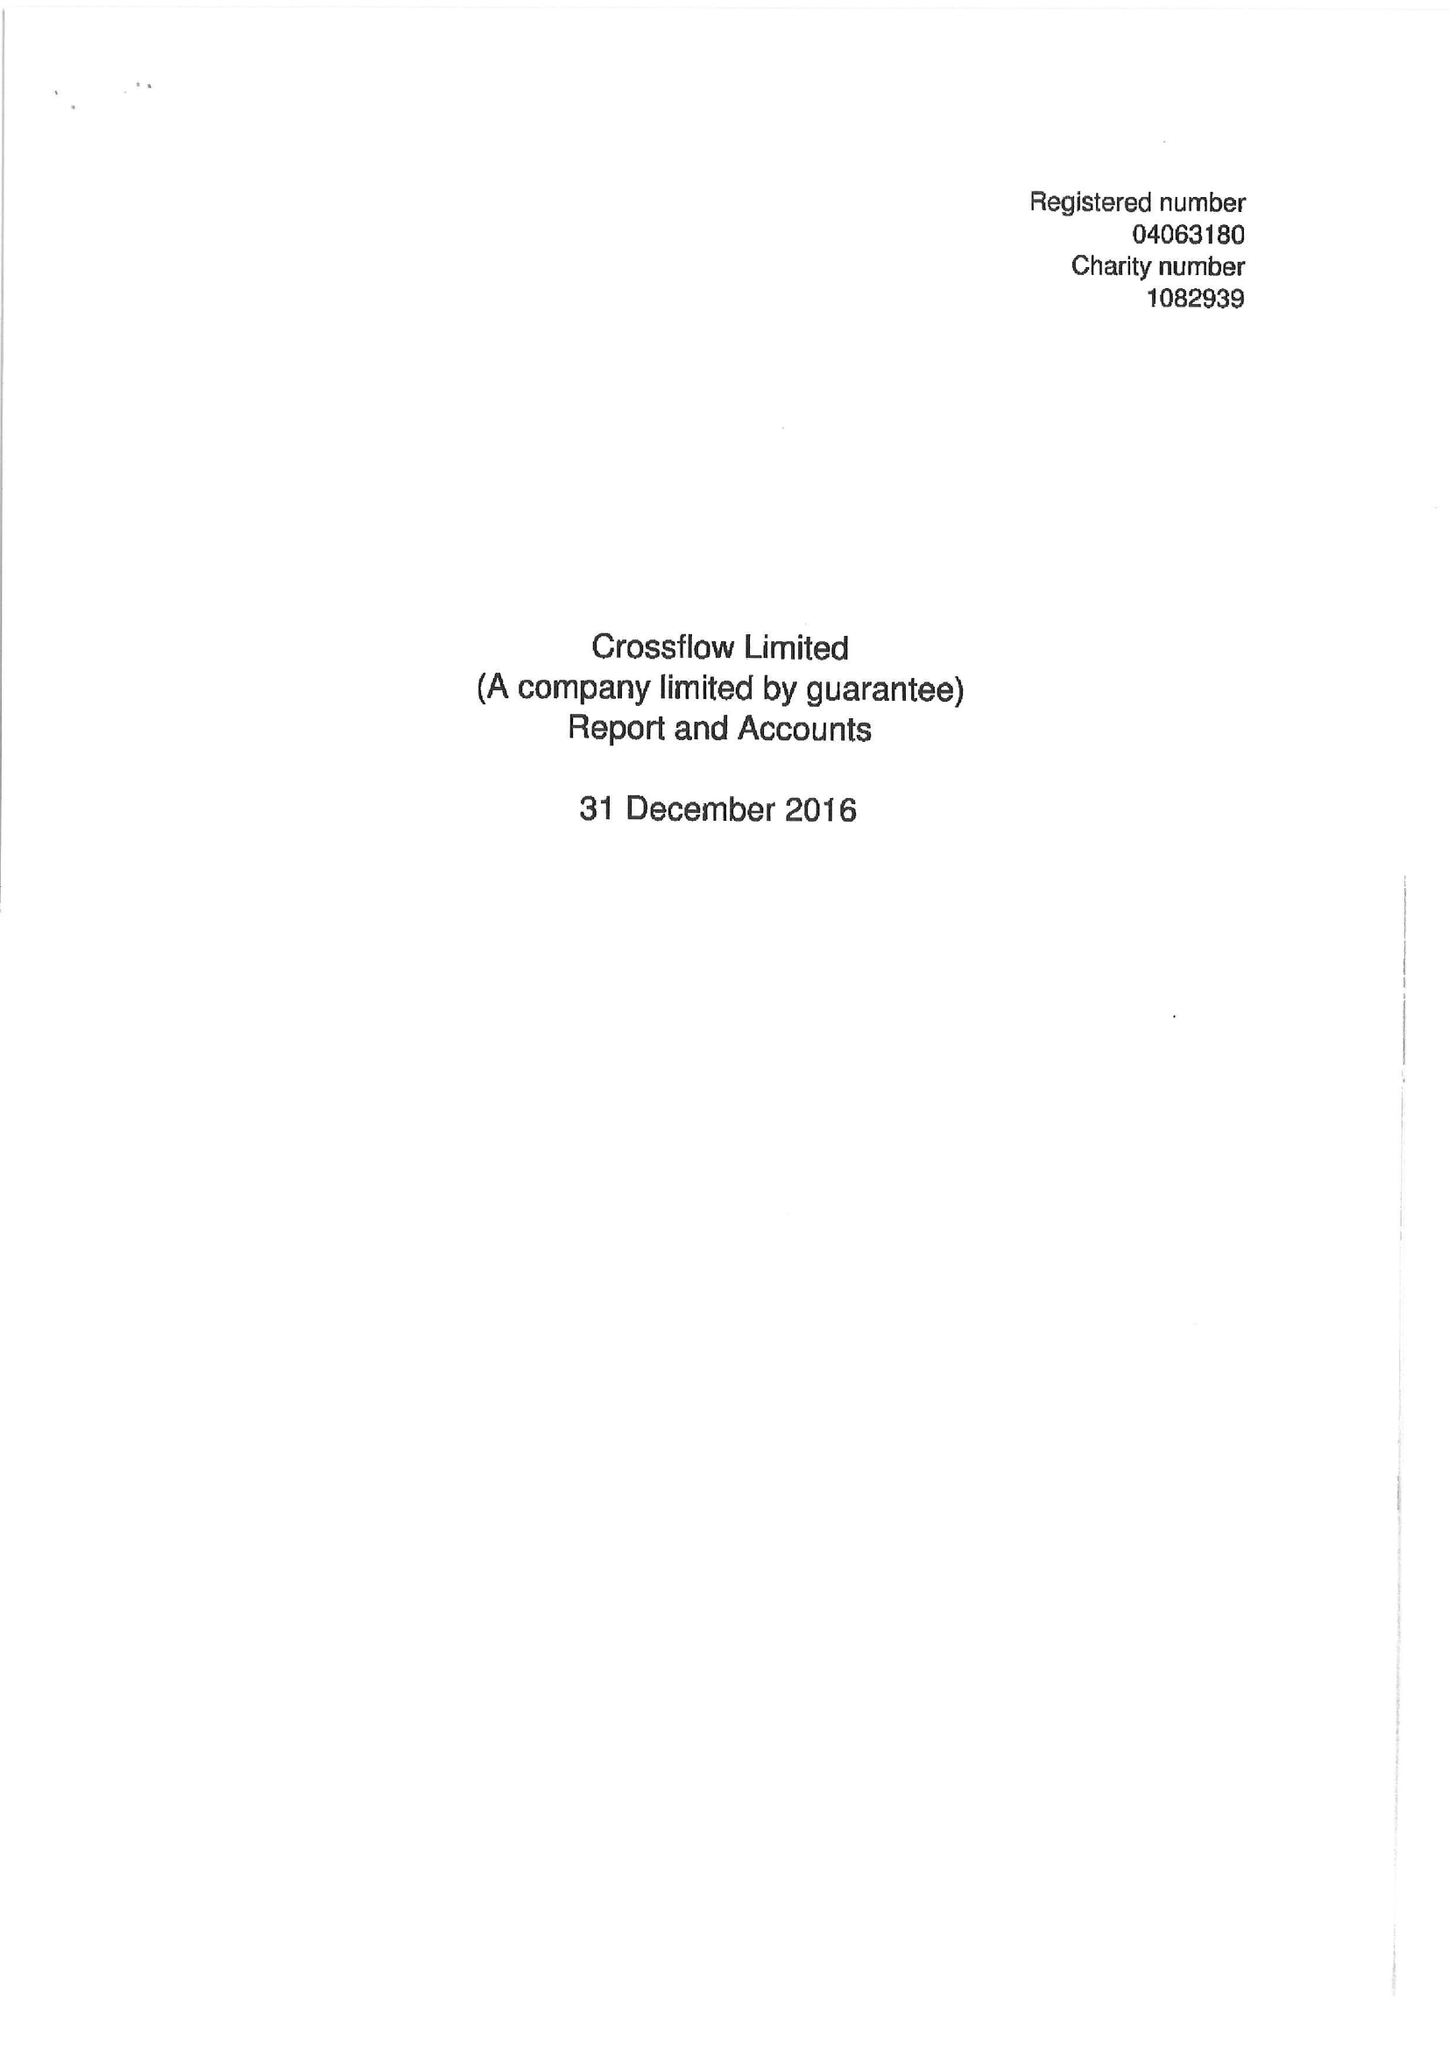What is the value for the income_annually_in_british_pounds?
Answer the question using a single word or phrase. 129050.00 